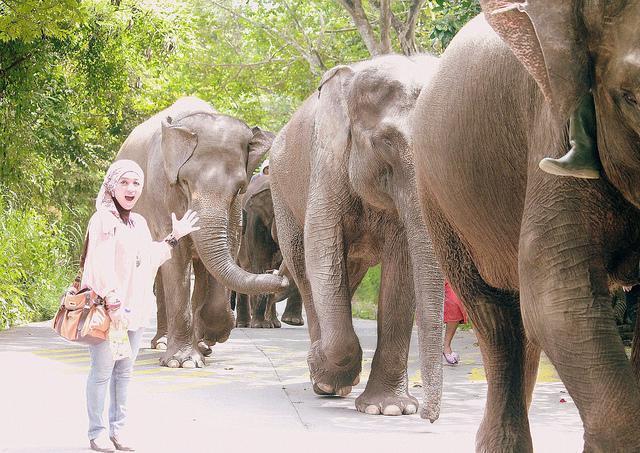What does this animal tend to have?
Answer the question by selecting the correct answer among the 4 following choices.
Options: Wings, two trunks, sharp teeth, three hearts. Two trunks. What is the expression on the woman's face?
Select the accurate answer and provide justification: `Answer: choice
Rationale: srationale.`
Options: Worry, scare, excitement, disgust. Answer: excitement.
Rationale: Her mouth is wide open and smiling 